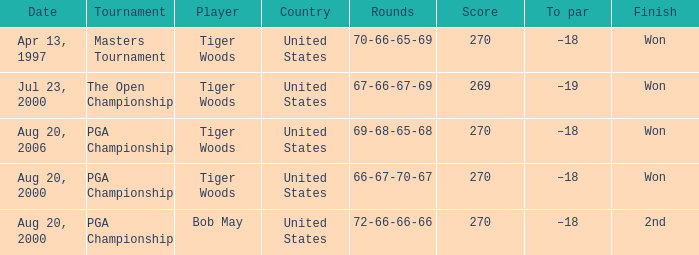What is the worst (highest) score? 270.0. 